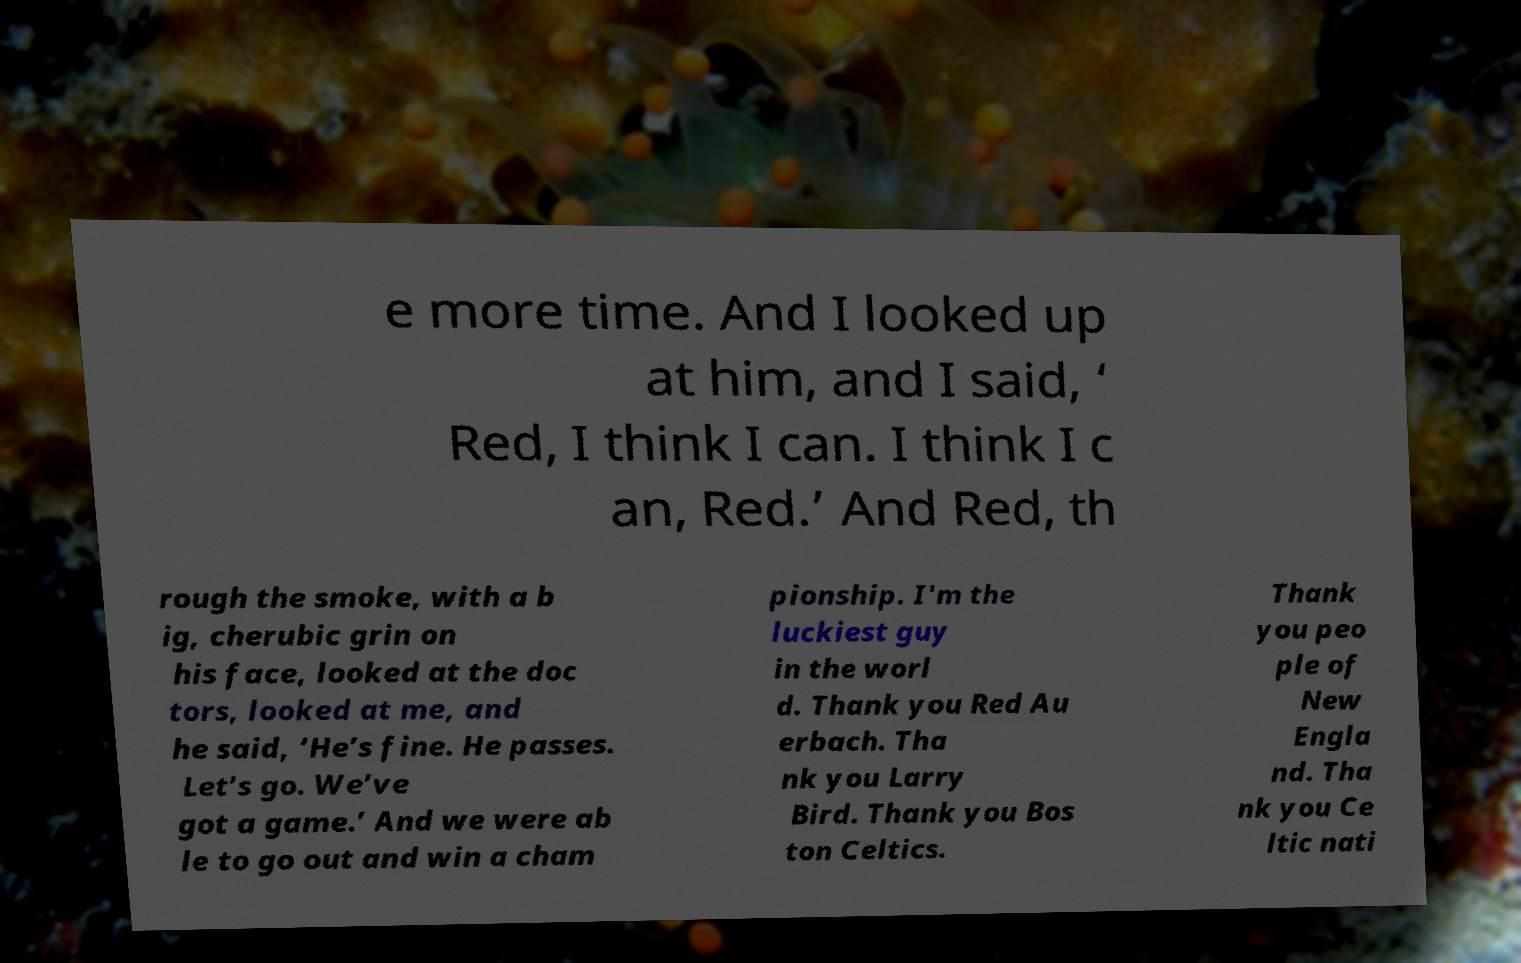Could you assist in decoding the text presented in this image and type it out clearly? e more time. And I looked up at him, and I said, ‘ Red, I think I can. I think I c an, Red.’ And Red, th rough the smoke, with a b ig, cherubic grin on his face, looked at the doc tors, looked at me, and he said, ‘He’s fine. He passes. Let’s go. We’ve got a game.’ And we were ab le to go out and win a cham pionship. I'm the luckiest guy in the worl d. Thank you Red Au erbach. Tha nk you Larry Bird. Thank you Bos ton Celtics. Thank you peo ple of New Engla nd. Tha nk you Ce ltic nati 